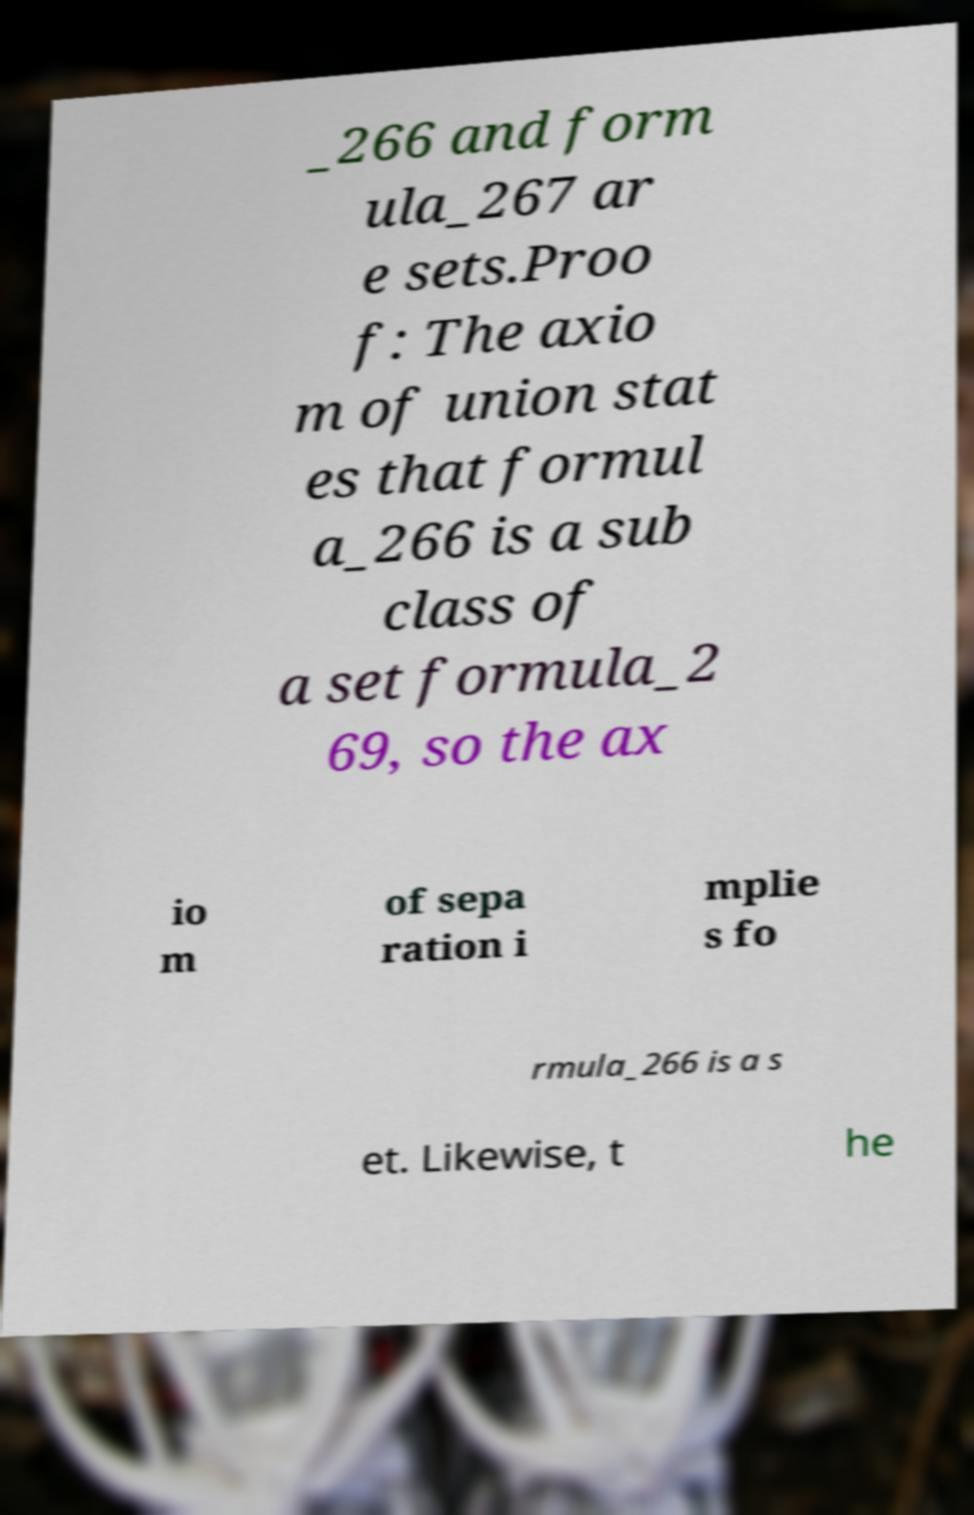Please read and relay the text visible in this image. What does it say? _266 and form ula_267 ar e sets.Proo f: The axio m of union stat es that formul a_266 is a sub class of a set formula_2 69, so the ax io m of sepa ration i mplie s fo rmula_266 is a s et. Likewise, t he 